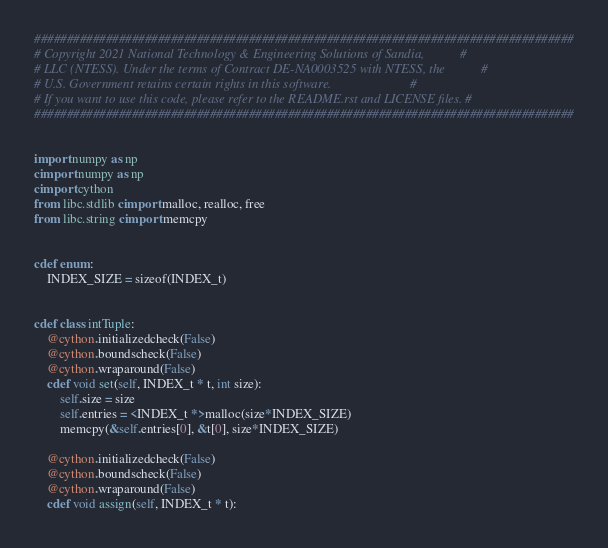<code> <loc_0><loc_0><loc_500><loc_500><_Cython_>###################################################################################
# Copyright 2021 National Technology & Engineering Solutions of Sandia,           #
# LLC (NTESS). Under the terms of Contract DE-NA0003525 with NTESS, the           #
# U.S. Government retains certain rights in this software.                        #
# If you want to use this code, please refer to the README.rst and LICENSE files. #
###################################################################################


import numpy as np
cimport numpy as np
cimport cython
from libc.stdlib cimport malloc, realloc, free
from libc.string cimport memcpy


cdef enum:
    INDEX_SIZE = sizeof(INDEX_t)


cdef class intTuple:
    @cython.initializedcheck(False)
    @cython.boundscheck(False)
    @cython.wraparound(False)
    cdef void set(self, INDEX_t * t, int size):
        self.size = size
        self.entries = <INDEX_t *>malloc(size*INDEX_SIZE)
        memcpy(&self.entries[0], &t[0], size*INDEX_SIZE)

    @cython.initializedcheck(False)
    @cython.boundscheck(False)
    @cython.wraparound(False)
    cdef void assign(self, INDEX_t * t):</code> 